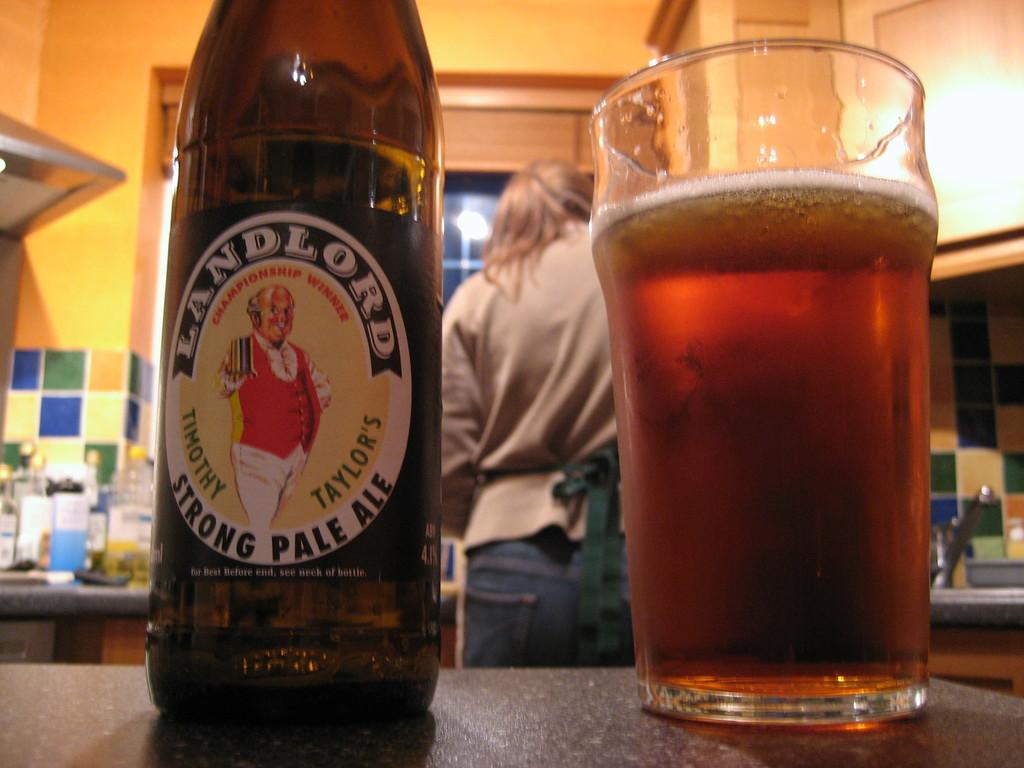What kind of pale ale is this?
Offer a very short reply. Strong. 